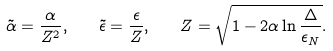<formula> <loc_0><loc_0><loc_500><loc_500>\tilde { \alpha } = \frac { \alpha } { Z ^ { 2 } } , \quad \tilde { \epsilon } = \frac { \epsilon } { Z } , \quad Z = \sqrt { 1 - 2 \alpha \ln \frac { \Delta } { \epsilon _ { N } } } .</formula> 